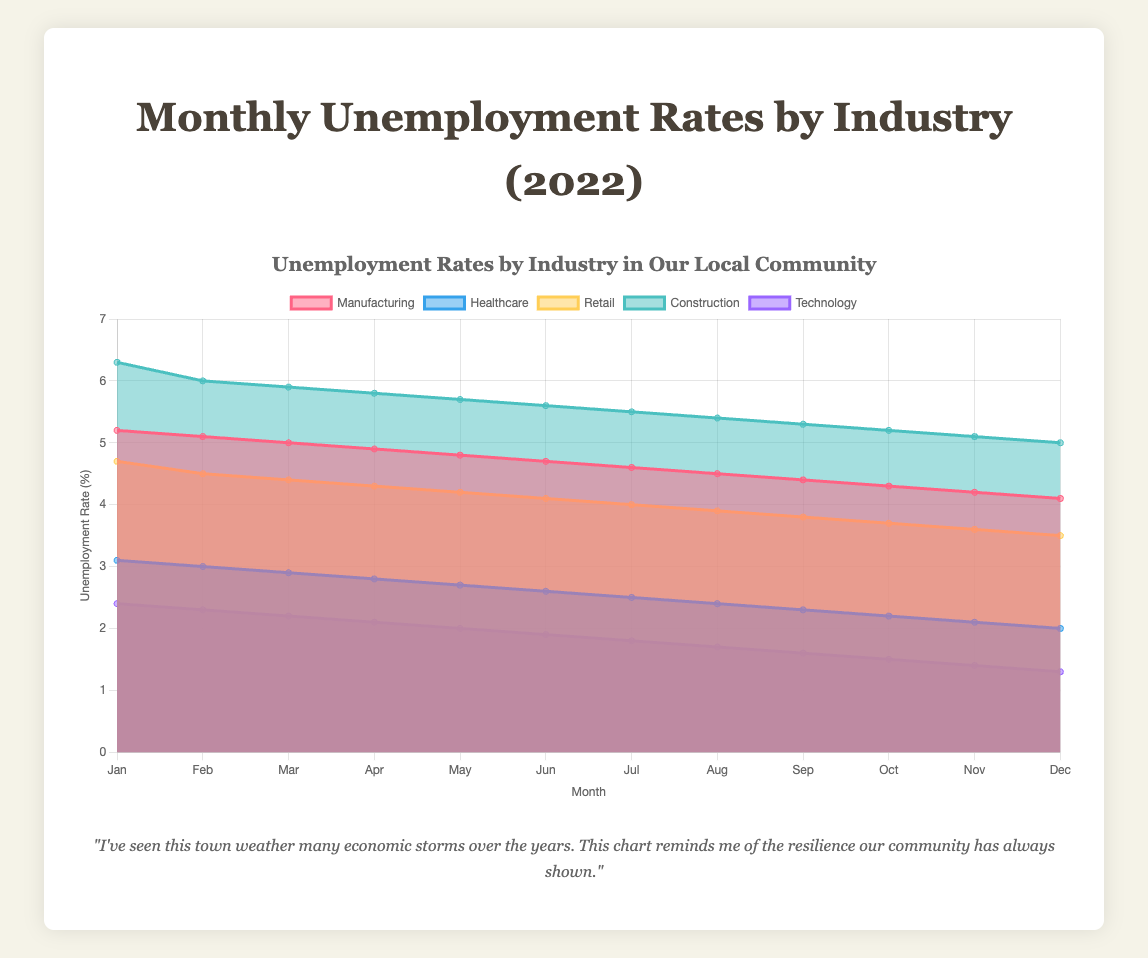What is the title of the figure? The title of the figure is prominently displayed at the top. It reads "Monthly Unemployment Rates by Industry (2022)."
Answer: Monthly Unemployment Rates by Industry (2022) Which industry had the highest unemployment rate in January 2022? Look at the data for January 2022. The industries are Manufacturing, Healthcare, Retail, Construction, and Technology. The highest unemployment rate in January is in Construction with 6.3%.
Answer: Construction What is the trend of unemployment rates in the Manufacturing sector throughout 2022? Examining the Manufacturing data points from January to December, the unemployment rate decreases consistently from 5.2% to 4.1%.
Answer: Downward trend Which industry had the lowest unemployment rate in July 2022? Review the unemployment rates for all industries in July 2022. The data shows Technology has the lowest unemployment rate at 1.8%.
Answer: Technology Comparing January and December 2022, how much did the unemployment rate decrease in the Healthcare industry? Subtract the unemployment rate in December from that in January (3.1% - 2.0%). This results in a decrease of 1.1%.
Answer: 1.1% What is the overall trend in the unemployment rate for the Technology sector over the year 2022? Observing the Technology sector, the unemployment rate decreases steadily from January's 2.4% to December's 1.3%.
Answer: Downward trend Which sector maintained the most consistent decline in unemployment rates during 2022? All sectors decreased over the year, but Technology shows a uniform decrease each month.
Answer: Technology How does the unemployment rate in the Construction industry in May compare to that in October 2022? Refer to May and October data for Construction; May has a rate of 5.7% while October has a rate of 5.2%, thus a decrease of 0.5%.
Answer: 0.5% lower in October What was the average unemployment rate in the Retail sector for the first quarter of 2022? Add the Retail unemployment rates for Jan (4.7%), Feb (4.5%), and Mar (4.4%), then divide by 3: (4.7 + 4.5 + 4.4) / 3 = 4.53%.
Answer: 4.53% Which month showed the largest decrease in unemployment rate for the Manufacturing sector? Calculate the monthly difference for Manufacturing, the largest decrease occurs between January (5.2%) and February (5.1%), March (5.0%), etc. The largest decrease (0.1%) is consistent each month, thus equal.
Answer: Equal decrease each month 